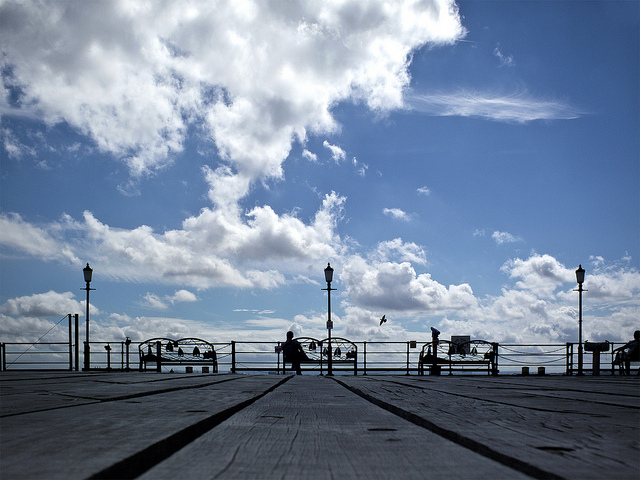<image>What land feature is in the background? I don't know what land feature is in the background. It could be mountains, a boardwalk, a dock, clouds, or the ocean. What land feature is in the background? It is unclear what land feature is in the background. It could be mountains, a boardwalk, a dock, or none at all. 